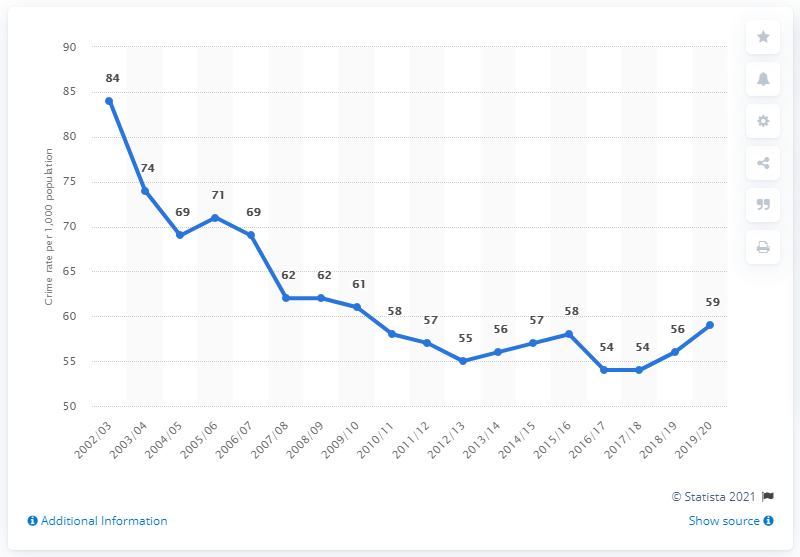Identify some key points in this picture. In the years 2002/2003 and 2003/2004, the crime rate in Northern Ireland was 74%. Northern Ireland's crime rate in 2019/20 was 59%. 